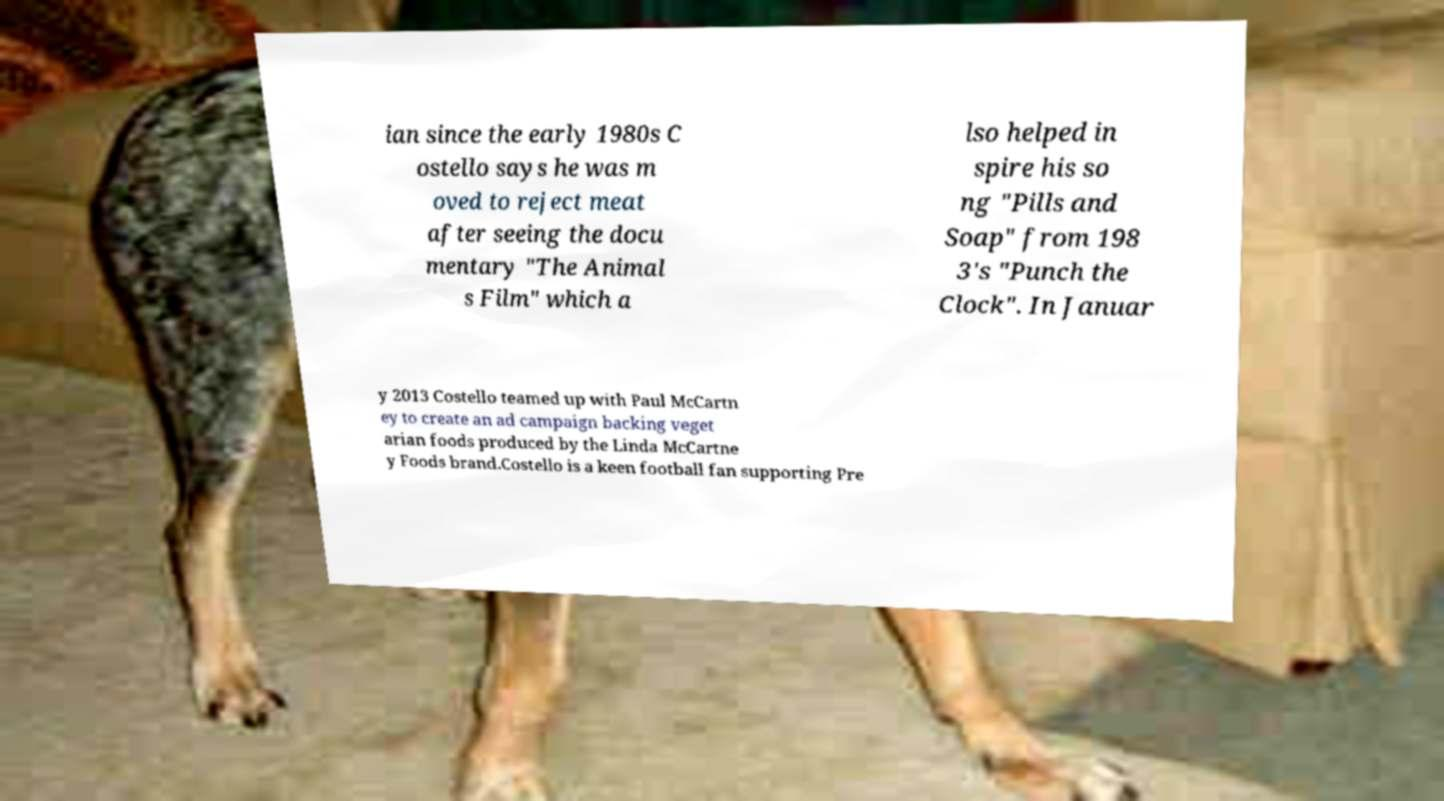Could you extract and type out the text from this image? ian since the early 1980s C ostello says he was m oved to reject meat after seeing the docu mentary "The Animal s Film" which a lso helped in spire his so ng "Pills and Soap" from 198 3's "Punch the Clock". In Januar y 2013 Costello teamed up with Paul McCartn ey to create an ad campaign backing veget arian foods produced by the Linda McCartne y Foods brand.Costello is a keen football fan supporting Pre 